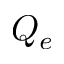<formula> <loc_0><loc_0><loc_500><loc_500>Q _ { e }</formula> 